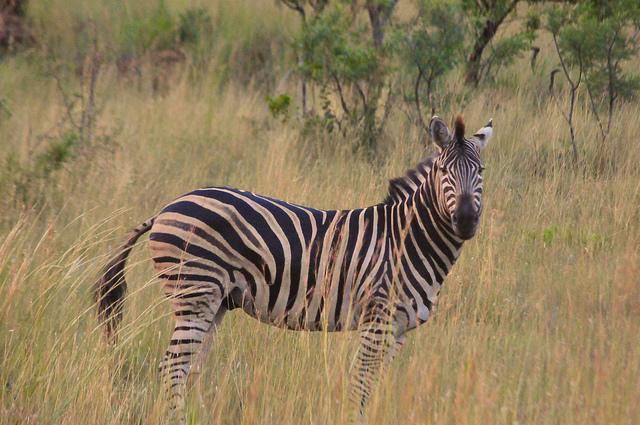How many zebras do you see?
Give a very brief answer. 1. 